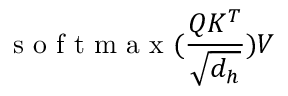Convert formula to latex. <formula><loc_0><loc_0><loc_500><loc_500>s o f t \max ( { \frac { Q K ^ { T } } { \sqrt { d _ { h } } } } ) V</formula> 